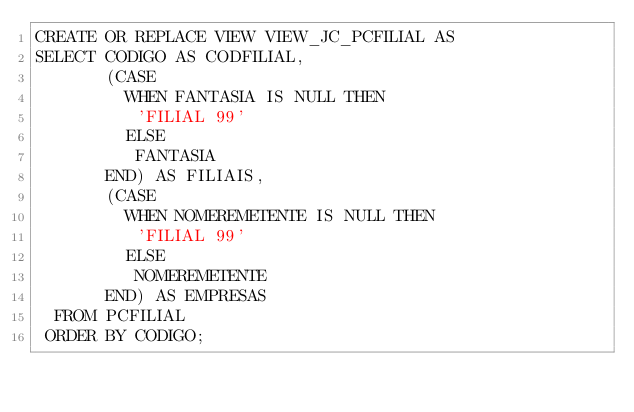Convert code to text. <code><loc_0><loc_0><loc_500><loc_500><_SQL_>CREATE OR REPLACE VIEW VIEW_JC_PCFILIAL AS
SELECT CODIGO AS CODFILIAL,
       (CASE
         WHEN FANTASIA IS NULL THEN
          'FILIAL 99'
         ELSE
          FANTASIA
       END) AS FILIAIS,
       (CASE
         WHEN NOMEREMETENTE IS NULL THEN
          'FILIAL 99'
         ELSE
          NOMEREMETENTE
       END) AS EMPRESAS
  FROM PCFILIAL
 ORDER BY CODIGO;
</code> 